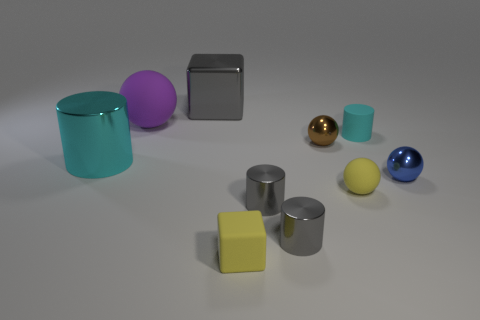Subtract 1 cylinders. How many cylinders are left? 3 Subtract all cylinders. How many objects are left? 6 Add 5 gray metallic cylinders. How many gray metallic cylinders exist? 7 Subtract 1 yellow cubes. How many objects are left? 9 Subtract all small spheres. Subtract all big cyan metallic things. How many objects are left? 6 Add 5 blue metal objects. How many blue metal objects are left? 6 